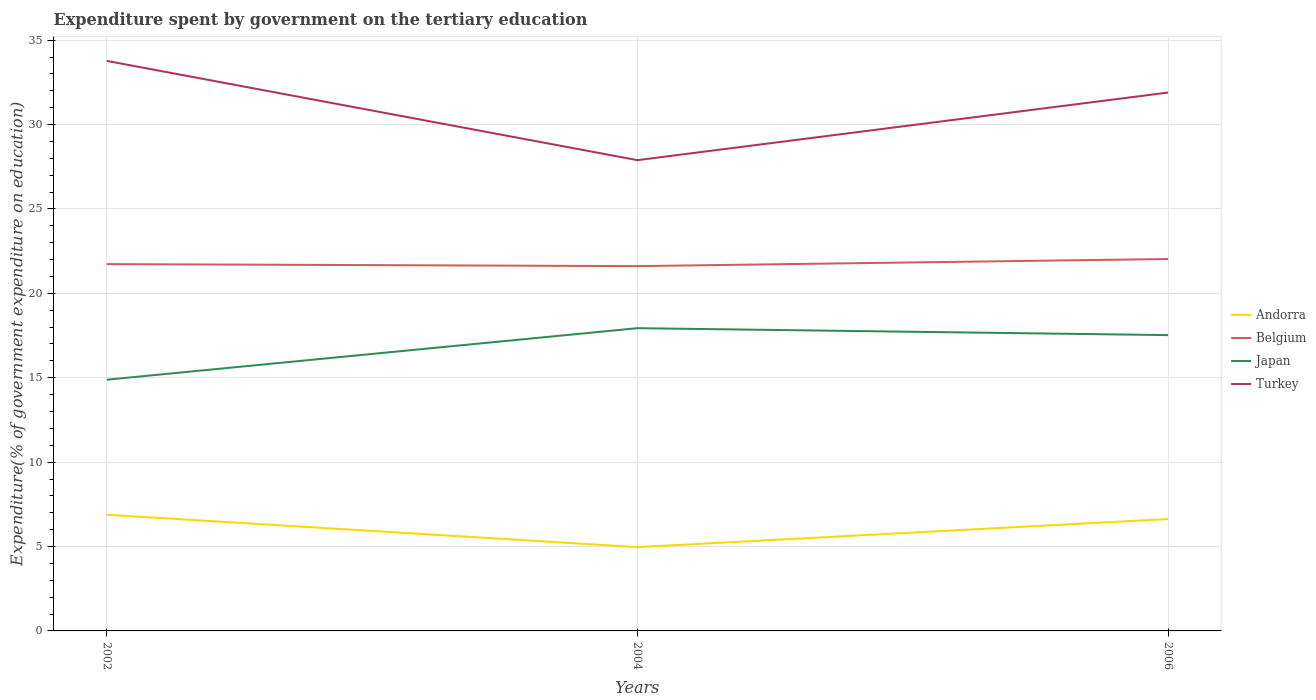Does the line corresponding to Japan intersect with the line corresponding to Turkey?
Ensure brevity in your answer.  No. Across all years, what is the maximum expenditure spent by government on the tertiary education in Turkey?
Your response must be concise. 27.89. In which year was the expenditure spent by government on the tertiary education in Turkey maximum?
Your answer should be compact. 2004. What is the total expenditure spent by government on the tertiary education in Andorra in the graph?
Your answer should be compact. -1.66. What is the difference between the highest and the second highest expenditure spent by government on the tertiary education in Andorra?
Make the answer very short. 1.92. Is the expenditure spent by government on the tertiary education in Belgium strictly greater than the expenditure spent by government on the tertiary education in Andorra over the years?
Give a very brief answer. No. Does the graph contain grids?
Keep it short and to the point. Yes. Where does the legend appear in the graph?
Give a very brief answer. Center right. What is the title of the graph?
Provide a succinct answer. Expenditure spent by government on the tertiary education. What is the label or title of the X-axis?
Provide a short and direct response. Years. What is the label or title of the Y-axis?
Your answer should be very brief. Expenditure(% of government expenditure on education). What is the Expenditure(% of government expenditure on education) of Andorra in 2002?
Make the answer very short. 6.88. What is the Expenditure(% of government expenditure on education) of Belgium in 2002?
Keep it short and to the point. 21.73. What is the Expenditure(% of government expenditure on education) of Japan in 2002?
Provide a short and direct response. 14.88. What is the Expenditure(% of government expenditure on education) of Turkey in 2002?
Your answer should be compact. 33.77. What is the Expenditure(% of government expenditure on education) of Andorra in 2004?
Provide a short and direct response. 4.96. What is the Expenditure(% of government expenditure on education) of Belgium in 2004?
Offer a very short reply. 21.61. What is the Expenditure(% of government expenditure on education) of Japan in 2004?
Your response must be concise. 17.94. What is the Expenditure(% of government expenditure on education) of Turkey in 2004?
Your answer should be compact. 27.89. What is the Expenditure(% of government expenditure on education) in Andorra in 2006?
Offer a very short reply. 6.63. What is the Expenditure(% of government expenditure on education) of Belgium in 2006?
Your response must be concise. 22.03. What is the Expenditure(% of government expenditure on education) of Japan in 2006?
Provide a short and direct response. 17.53. What is the Expenditure(% of government expenditure on education) in Turkey in 2006?
Offer a very short reply. 31.9. Across all years, what is the maximum Expenditure(% of government expenditure on education) of Andorra?
Provide a short and direct response. 6.88. Across all years, what is the maximum Expenditure(% of government expenditure on education) in Belgium?
Make the answer very short. 22.03. Across all years, what is the maximum Expenditure(% of government expenditure on education) of Japan?
Offer a terse response. 17.94. Across all years, what is the maximum Expenditure(% of government expenditure on education) in Turkey?
Make the answer very short. 33.77. Across all years, what is the minimum Expenditure(% of government expenditure on education) of Andorra?
Provide a succinct answer. 4.96. Across all years, what is the minimum Expenditure(% of government expenditure on education) of Belgium?
Keep it short and to the point. 21.61. Across all years, what is the minimum Expenditure(% of government expenditure on education) of Japan?
Provide a succinct answer. 14.88. Across all years, what is the minimum Expenditure(% of government expenditure on education) of Turkey?
Your answer should be very brief. 27.89. What is the total Expenditure(% of government expenditure on education) in Andorra in the graph?
Offer a very short reply. 18.47. What is the total Expenditure(% of government expenditure on education) in Belgium in the graph?
Provide a succinct answer. 65.38. What is the total Expenditure(% of government expenditure on education) in Japan in the graph?
Give a very brief answer. 50.35. What is the total Expenditure(% of government expenditure on education) in Turkey in the graph?
Your answer should be very brief. 93.56. What is the difference between the Expenditure(% of government expenditure on education) in Andorra in 2002 and that in 2004?
Provide a short and direct response. 1.92. What is the difference between the Expenditure(% of government expenditure on education) of Belgium in 2002 and that in 2004?
Offer a very short reply. 0.12. What is the difference between the Expenditure(% of government expenditure on education) of Japan in 2002 and that in 2004?
Your answer should be compact. -3.05. What is the difference between the Expenditure(% of government expenditure on education) of Turkey in 2002 and that in 2004?
Ensure brevity in your answer.  5.88. What is the difference between the Expenditure(% of government expenditure on education) in Andorra in 2002 and that in 2006?
Make the answer very short. 0.25. What is the difference between the Expenditure(% of government expenditure on education) of Belgium in 2002 and that in 2006?
Offer a terse response. -0.3. What is the difference between the Expenditure(% of government expenditure on education) of Japan in 2002 and that in 2006?
Offer a terse response. -2.64. What is the difference between the Expenditure(% of government expenditure on education) of Turkey in 2002 and that in 2006?
Your answer should be compact. 1.88. What is the difference between the Expenditure(% of government expenditure on education) in Andorra in 2004 and that in 2006?
Your response must be concise. -1.66. What is the difference between the Expenditure(% of government expenditure on education) in Belgium in 2004 and that in 2006?
Offer a terse response. -0.42. What is the difference between the Expenditure(% of government expenditure on education) in Japan in 2004 and that in 2006?
Give a very brief answer. 0.41. What is the difference between the Expenditure(% of government expenditure on education) of Turkey in 2004 and that in 2006?
Make the answer very short. -4.01. What is the difference between the Expenditure(% of government expenditure on education) in Andorra in 2002 and the Expenditure(% of government expenditure on education) in Belgium in 2004?
Your answer should be very brief. -14.73. What is the difference between the Expenditure(% of government expenditure on education) in Andorra in 2002 and the Expenditure(% of government expenditure on education) in Japan in 2004?
Your answer should be very brief. -11.05. What is the difference between the Expenditure(% of government expenditure on education) of Andorra in 2002 and the Expenditure(% of government expenditure on education) of Turkey in 2004?
Your answer should be compact. -21.01. What is the difference between the Expenditure(% of government expenditure on education) of Belgium in 2002 and the Expenditure(% of government expenditure on education) of Japan in 2004?
Your response must be concise. 3.79. What is the difference between the Expenditure(% of government expenditure on education) of Belgium in 2002 and the Expenditure(% of government expenditure on education) of Turkey in 2004?
Ensure brevity in your answer.  -6.16. What is the difference between the Expenditure(% of government expenditure on education) in Japan in 2002 and the Expenditure(% of government expenditure on education) in Turkey in 2004?
Give a very brief answer. -13.01. What is the difference between the Expenditure(% of government expenditure on education) in Andorra in 2002 and the Expenditure(% of government expenditure on education) in Belgium in 2006?
Your response must be concise. -15.15. What is the difference between the Expenditure(% of government expenditure on education) of Andorra in 2002 and the Expenditure(% of government expenditure on education) of Japan in 2006?
Provide a short and direct response. -10.64. What is the difference between the Expenditure(% of government expenditure on education) in Andorra in 2002 and the Expenditure(% of government expenditure on education) in Turkey in 2006?
Provide a short and direct response. -25.01. What is the difference between the Expenditure(% of government expenditure on education) in Belgium in 2002 and the Expenditure(% of government expenditure on education) in Japan in 2006?
Offer a very short reply. 4.21. What is the difference between the Expenditure(% of government expenditure on education) of Belgium in 2002 and the Expenditure(% of government expenditure on education) of Turkey in 2006?
Your answer should be compact. -10.16. What is the difference between the Expenditure(% of government expenditure on education) of Japan in 2002 and the Expenditure(% of government expenditure on education) of Turkey in 2006?
Your answer should be very brief. -17.01. What is the difference between the Expenditure(% of government expenditure on education) of Andorra in 2004 and the Expenditure(% of government expenditure on education) of Belgium in 2006?
Provide a short and direct response. -17.07. What is the difference between the Expenditure(% of government expenditure on education) of Andorra in 2004 and the Expenditure(% of government expenditure on education) of Japan in 2006?
Offer a very short reply. -12.56. What is the difference between the Expenditure(% of government expenditure on education) in Andorra in 2004 and the Expenditure(% of government expenditure on education) in Turkey in 2006?
Offer a very short reply. -26.93. What is the difference between the Expenditure(% of government expenditure on education) of Belgium in 2004 and the Expenditure(% of government expenditure on education) of Japan in 2006?
Offer a terse response. 4.09. What is the difference between the Expenditure(% of government expenditure on education) in Belgium in 2004 and the Expenditure(% of government expenditure on education) in Turkey in 2006?
Keep it short and to the point. -10.28. What is the difference between the Expenditure(% of government expenditure on education) of Japan in 2004 and the Expenditure(% of government expenditure on education) of Turkey in 2006?
Keep it short and to the point. -13.96. What is the average Expenditure(% of government expenditure on education) of Andorra per year?
Give a very brief answer. 6.16. What is the average Expenditure(% of government expenditure on education) in Belgium per year?
Give a very brief answer. 21.79. What is the average Expenditure(% of government expenditure on education) in Japan per year?
Ensure brevity in your answer.  16.78. What is the average Expenditure(% of government expenditure on education) in Turkey per year?
Give a very brief answer. 31.19. In the year 2002, what is the difference between the Expenditure(% of government expenditure on education) of Andorra and Expenditure(% of government expenditure on education) of Belgium?
Ensure brevity in your answer.  -14.85. In the year 2002, what is the difference between the Expenditure(% of government expenditure on education) in Andorra and Expenditure(% of government expenditure on education) in Japan?
Offer a very short reply. -8. In the year 2002, what is the difference between the Expenditure(% of government expenditure on education) of Andorra and Expenditure(% of government expenditure on education) of Turkey?
Offer a terse response. -26.89. In the year 2002, what is the difference between the Expenditure(% of government expenditure on education) of Belgium and Expenditure(% of government expenditure on education) of Japan?
Ensure brevity in your answer.  6.85. In the year 2002, what is the difference between the Expenditure(% of government expenditure on education) in Belgium and Expenditure(% of government expenditure on education) in Turkey?
Your answer should be compact. -12.04. In the year 2002, what is the difference between the Expenditure(% of government expenditure on education) in Japan and Expenditure(% of government expenditure on education) in Turkey?
Make the answer very short. -18.89. In the year 2004, what is the difference between the Expenditure(% of government expenditure on education) of Andorra and Expenditure(% of government expenditure on education) of Belgium?
Provide a short and direct response. -16.65. In the year 2004, what is the difference between the Expenditure(% of government expenditure on education) in Andorra and Expenditure(% of government expenditure on education) in Japan?
Provide a short and direct response. -12.97. In the year 2004, what is the difference between the Expenditure(% of government expenditure on education) of Andorra and Expenditure(% of government expenditure on education) of Turkey?
Make the answer very short. -22.93. In the year 2004, what is the difference between the Expenditure(% of government expenditure on education) of Belgium and Expenditure(% of government expenditure on education) of Japan?
Provide a succinct answer. 3.68. In the year 2004, what is the difference between the Expenditure(% of government expenditure on education) in Belgium and Expenditure(% of government expenditure on education) in Turkey?
Your answer should be compact. -6.28. In the year 2004, what is the difference between the Expenditure(% of government expenditure on education) in Japan and Expenditure(% of government expenditure on education) in Turkey?
Provide a short and direct response. -9.95. In the year 2006, what is the difference between the Expenditure(% of government expenditure on education) in Andorra and Expenditure(% of government expenditure on education) in Belgium?
Your answer should be very brief. -15.41. In the year 2006, what is the difference between the Expenditure(% of government expenditure on education) of Andorra and Expenditure(% of government expenditure on education) of Japan?
Offer a terse response. -10.9. In the year 2006, what is the difference between the Expenditure(% of government expenditure on education) in Andorra and Expenditure(% of government expenditure on education) in Turkey?
Ensure brevity in your answer.  -25.27. In the year 2006, what is the difference between the Expenditure(% of government expenditure on education) of Belgium and Expenditure(% of government expenditure on education) of Japan?
Make the answer very short. 4.51. In the year 2006, what is the difference between the Expenditure(% of government expenditure on education) in Belgium and Expenditure(% of government expenditure on education) in Turkey?
Offer a very short reply. -9.86. In the year 2006, what is the difference between the Expenditure(% of government expenditure on education) in Japan and Expenditure(% of government expenditure on education) in Turkey?
Offer a terse response. -14.37. What is the ratio of the Expenditure(% of government expenditure on education) in Andorra in 2002 to that in 2004?
Keep it short and to the point. 1.39. What is the ratio of the Expenditure(% of government expenditure on education) in Belgium in 2002 to that in 2004?
Keep it short and to the point. 1.01. What is the ratio of the Expenditure(% of government expenditure on education) of Japan in 2002 to that in 2004?
Your answer should be compact. 0.83. What is the ratio of the Expenditure(% of government expenditure on education) in Turkey in 2002 to that in 2004?
Ensure brevity in your answer.  1.21. What is the ratio of the Expenditure(% of government expenditure on education) in Andorra in 2002 to that in 2006?
Your answer should be very brief. 1.04. What is the ratio of the Expenditure(% of government expenditure on education) in Belgium in 2002 to that in 2006?
Give a very brief answer. 0.99. What is the ratio of the Expenditure(% of government expenditure on education) in Japan in 2002 to that in 2006?
Offer a very short reply. 0.85. What is the ratio of the Expenditure(% of government expenditure on education) of Turkey in 2002 to that in 2006?
Provide a succinct answer. 1.06. What is the ratio of the Expenditure(% of government expenditure on education) in Andorra in 2004 to that in 2006?
Offer a very short reply. 0.75. What is the ratio of the Expenditure(% of government expenditure on education) in Belgium in 2004 to that in 2006?
Your answer should be compact. 0.98. What is the ratio of the Expenditure(% of government expenditure on education) of Japan in 2004 to that in 2006?
Offer a terse response. 1.02. What is the ratio of the Expenditure(% of government expenditure on education) of Turkey in 2004 to that in 2006?
Give a very brief answer. 0.87. What is the difference between the highest and the second highest Expenditure(% of government expenditure on education) in Andorra?
Provide a short and direct response. 0.25. What is the difference between the highest and the second highest Expenditure(% of government expenditure on education) in Belgium?
Offer a terse response. 0.3. What is the difference between the highest and the second highest Expenditure(% of government expenditure on education) in Japan?
Ensure brevity in your answer.  0.41. What is the difference between the highest and the second highest Expenditure(% of government expenditure on education) in Turkey?
Give a very brief answer. 1.88. What is the difference between the highest and the lowest Expenditure(% of government expenditure on education) of Andorra?
Give a very brief answer. 1.92. What is the difference between the highest and the lowest Expenditure(% of government expenditure on education) of Belgium?
Offer a terse response. 0.42. What is the difference between the highest and the lowest Expenditure(% of government expenditure on education) of Japan?
Your answer should be very brief. 3.05. What is the difference between the highest and the lowest Expenditure(% of government expenditure on education) in Turkey?
Ensure brevity in your answer.  5.88. 